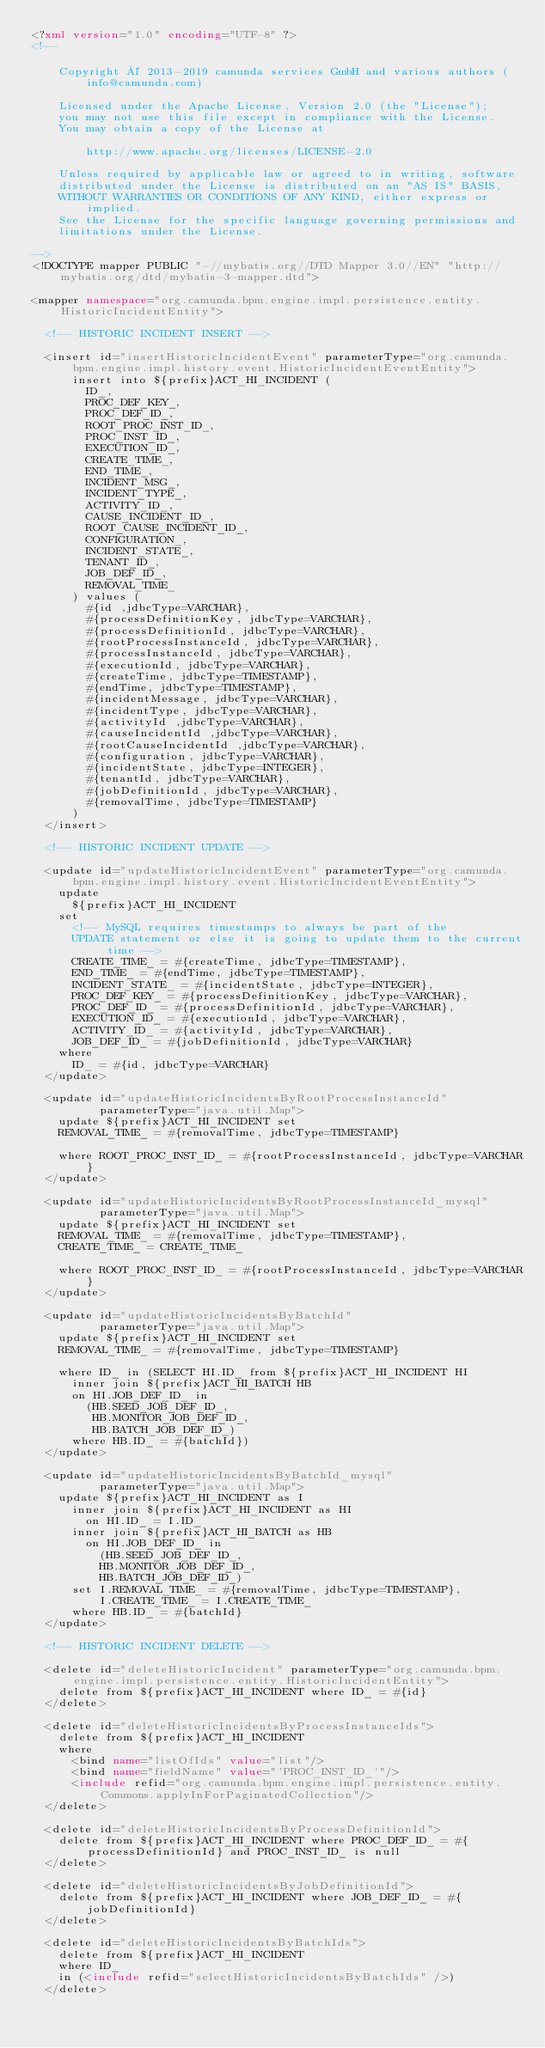Convert code to text. <code><loc_0><loc_0><loc_500><loc_500><_XML_><?xml version="1.0" encoding="UTF-8" ?>
<!--

    Copyright © 2013-2019 camunda services GmbH and various authors (info@camunda.com)

    Licensed under the Apache License, Version 2.0 (the "License");
    you may not use this file except in compliance with the License.
    You may obtain a copy of the License at

        http://www.apache.org/licenses/LICENSE-2.0

    Unless required by applicable law or agreed to in writing, software
    distributed under the License is distributed on an "AS IS" BASIS,
    WITHOUT WARRANTIES OR CONDITIONS OF ANY KIND, either express or implied.
    See the License for the specific language governing permissions and
    limitations under the License.

-->
<!DOCTYPE mapper PUBLIC "-//mybatis.org//DTD Mapper 3.0//EN" "http://mybatis.org/dtd/mybatis-3-mapper.dtd">

<mapper namespace="org.camunda.bpm.engine.impl.persistence.entity.HistoricIncidentEntity">

  <!-- HISTORIC INCIDENT INSERT -->

  <insert id="insertHistoricIncidentEvent" parameterType="org.camunda.bpm.engine.impl.history.event.HistoricIncidentEventEntity">
      insert into ${prefix}ACT_HI_INCIDENT (
        ID_,
        PROC_DEF_KEY_,
        PROC_DEF_ID_,
        ROOT_PROC_INST_ID_,
        PROC_INST_ID_,
        EXECUTION_ID_,
        CREATE_TIME_,
        END_TIME_,
        INCIDENT_MSG_,
        INCIDENT_TYPE_,
        ACTIVITY_ID_,
        CAUSE_INCIDENT_ID_,
        ROOT_CAUSE_INCIDENT_ID_,
        CONFIGURATION_,
        INCIDENT_STATE_,
        TENANT_ID_,
        JOB_DEF_ID_,
        REMOVAL_TIME_
      ) values (
        #{id ,jdbcType=VARCHAR},
        #{processDefinitionKey, jdbcType=VARCHAR},
        #{processDefinitionId, jdbcType=VARCHAR},
        #{rootProcessInstanceId, jdbcType=VARCHAR},
        #{processInstanceId, jdbcType=VARCHAR},
        #{executionId, jdbcType=VARCHAR},
        #{createTime, jdbcType=TIMESTAMP},
        #{endTime, jdbcType=TIMESTAMP},
        #{incidentMessage, jdbcType=VARCHAR},
        #{incidentType, jdbcType=VARCHAR},
        #{activityId ,jdbcType=VARCHAR},
        #{causeIncidentId ,jdbcType=VARCHAR},
        #{rootCauseIncidentId ,jdbcType=VARCHAR},
        #{configuration, jdbcType=VARCHAR},
        #{incidentState, jdbcType=INTEGER},
        #{tenantId, jdbcType=VARCHAR},
        #{jobDefinitionId, jdbcType=VARCHAR},
        #{removalTime, jdbcType=TIMESTAMP}
      )
  </insert>

  <!-- HISTORIC INCIDENT UPDATE -->

  <update id="updateHistoricIncidentEvent" parameterType="org.camunda.bpm.engine.impl.history.event.HistoricIncidentEventEntity">
    update
      ${prefix}ACT_HI_INCIDENT
    set
      <!-- MySQL requires timestamps to always be part of the 
      UPDATE statement or else it is going to update them to the current time -->
      CREATE_TIME_ = #{createTime, jdbcType=TIMESTAMP},
      END_TIME_ = #{endTime, jdbcType=TIMESTAMP},
      INCIDENT_STATE_ = #{incidentState, jdbcType=INTEGER},
      PROC_DEF_KEY_ = #{processDefinitionKey, jdbcType=VARCHAR},
      PROC_DEF_ID_ = #{processDefinitionId, jdbcType=VARCHAR},
      EXECUTION_ID_ = #{executionId, jdbcType=VARCHAR},
      ACTIVITY_ID_ = #{activityId, jdbcType=VARCHAR},
      JOB_DEF_ID_ = #{jobDefinitionId, jdbcType=VARCHAR}
    where
      ID_ = #{id, jdbcType=VARCHAR}
  </update>

  <update id="updateHistoricIncidentsByRootProcessInstanceId"
          parameterType="java.util.Map">
    update ${prefix}ACT_HI_INCIDENT set
    REMOVAL_TIME_ = #{removalTime, jdbcType=TIMESTAMP}

    where ROOT_PROC_INST_ID_ = #{rootProcessInstanceId, jdbcType=VARCHAR}
  </update>

  <update id="updateHistoricIncidentsByRootProcessInstanceId_mysql"
          parameterType="java.util.Map">
    update ${prefix}ACT_HI_INCIDENT set
    REMOVAL_TIME_ = #{removalTime, jdbcType=TIMESTAMP},
    CREATE_TIME_ = CREATE_TIME_

    where ROOT_PROC_INST_ID_ = #{rootProcessInstanceId, jdbcType=VARCHAR}
  </update>

  <update id="updateHistoricIncidentsByBatchId"
          parameterType="java.util.Map">
    update ${prefix}ACT_HI_INCIDENT set
    REMOVAL_TIME_ = #{removalTime, jdbcType=TIMESTAMP}

    where ID_ in (SELECT HI.ID_ from ${prefix}ACT_HI_INCIDENT HI
      inner join ${prefix}ACT_HI_BATCH HB
      on HI.JOB_DEF_ID_ in
        (HB.SEED_JOB_DEF_ID_,
         HB.MONITOR_JOB_DEF_ID_,
         HB.BATCH_JOB_DEF_ID_)
      where HB.ID_ = #{batchId})
  </update>

  <update id="updateHistoricIncidentsByBatchId_mysql"
          parameterType="java.util.Map">
    update ${prefix}ACT_HI_INCIDENT as I
      inner join ${prefix}ACT_HI_INCIDENT as HI
        on HI.ID_ = I.ID_
      inner join ${prefix}ACT_HI_BATCH as HB
        on HI.JOB_DEF_ID_ in
          (HB.SEED_JOB_DEF_ID_,
          HB.MONITOR_JOB_DEF_ID_,
          HB.BATCH_JOB_DEF_ID_)
      set I.REMOVAL_TIME_ = #{removalTime, jdbcType=TIMESTAMP},
          I.CREATE_TIME_ = I.CREATE_TIME_
      where HB.ID_ = #{batchId}
  </update>

  <!-- HISTORIC INCIDENT DELETE -->

  <delete id="deleteHistoricIncident" parameterType="org.camunda.bpm.engine.impl.persistence.entity.HistoricIncidentEntity">
    delete from ${prefix}ACT_HI_INCIDENT where ID_ = #{id}
  </delete>

  <delete id="deleteHistoricIncidentsByProcessInstanceIds">
    delete from ${prefix}ACT_HI_INCIDENT
    where
      <bind name="listOfIds" value="list"/>
      <bind name="fieldName" value="'PROC_INST_ID_'"/>
      <include refid="org.camunda.bpm.engine.impl.persistence.entity.Commons.applyInForPaginatedCollection"/>
  </delete>

  <delete id="deleteHistoricIncidentsByProcessDefinitionId">
    delete from ${prefix}ACT_HI_INCIDENT where PROC_DEF_ID_ = #{processDefinitionId} and PROC_INST_ID_ is null
  </delete>

  <delete id="deleteHistoricIncidentsByJobDefinitionId">
    delete from ${prefix}ACT_HI_INCIDENT where JOB_DEF_ID_ = #{jobDefinitionId}
  </delete>

  <delete id="deleteHistoricIncidentsByBatchIds">
    delete from ${prefix}ACT_HI_INCIDENT
    where ID_
    in (<include refid="selectHistoricIncidentsByBatchIds" />)
  </delete>
</code> 